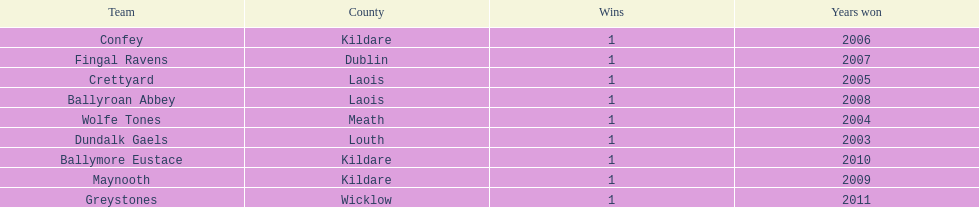What is the total of wins on the chart 9. 